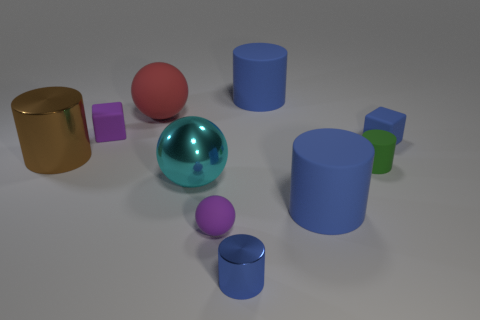Subtract all green rubber cylinders. How many cylinders are left? 4 Subtract all cyan spheres. How many spheres are left? 2 Subtract all spheres. How many objects are left? 7 Subtract all yellow spheres. Subtract all red blocks. How many spheres are left? 3 Subtract all green cylinders. How many red balls are left? 1 Subtract all large brown cylinders. Subtract all tiny green rubber objects. How many objects are left? 8 Add 1 large rubber cylinders. How many large rubber cylinders are left? 3 Add 6 large metal cylinders. How many large metal cylinders exist? 7 Subtract 0 yellow spheres. How many objects are left? 10 Subtract 1 cylinders. How many cylinders are left? 4 